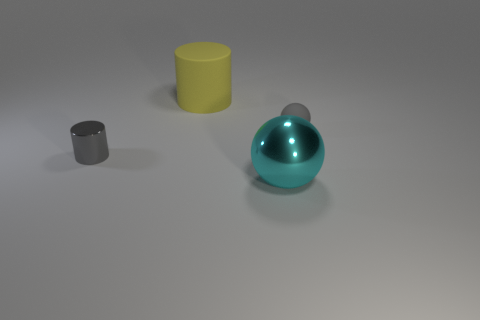Add 1 blue shiny cylinders. How many objects exist? 5 Add 2 brown rubber balls. How many brown rubber balls exist? 2 Subtract 0 cyan cylinders. How many objects are left? 4 Subtract all big metallic spheres. Subtract all big spheres. How many objects are left? 2 Add 2 big yellow rubber cylinders. How many big yellow rubber cylinders are left? 3 